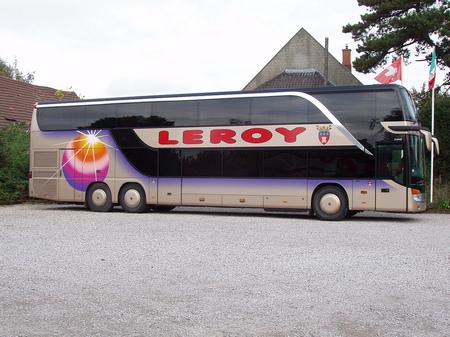How many doors in this?
Answer briefly. 1. What does the word on the side of the bus read?
Be succinct. Leroy. Is this bus on the road?
Write a very short answer. No. 